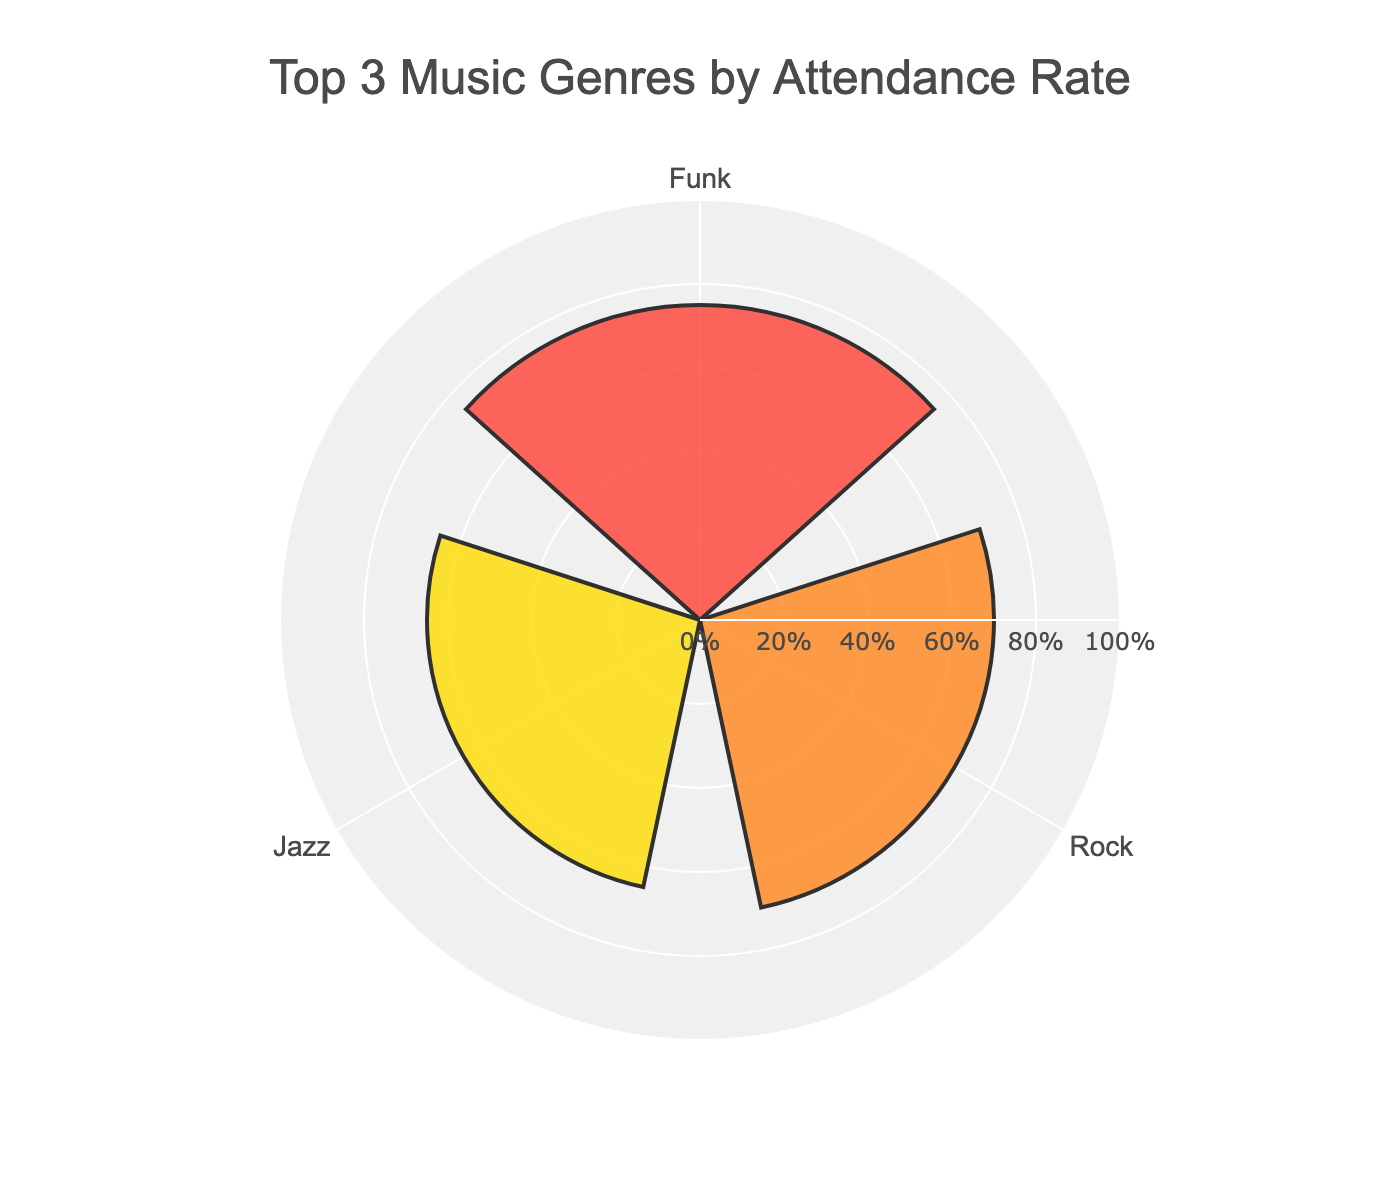What's the title of the chart? The title is placed at the top of the chart and is written in large, bold font.
Answer: Top 3 Music Genres by Attendance Rate What is the highest attendance rate among the music genres? The highest bar in the rose chart indicates the greatest attendance rate. The bar corresponding to Funk is the tallest.
Answer: 75% How many music genres are displayed in the figure? By counting the different labels on the angular axis, we see there are three different music genres.
Answer: 3 Which music genre has the lowest attendance rate among those shown? By comparing the heights of the bars, the shortest bar represents the lowest attendance rate. The Classical genre has the shortest bar.
Answer: Classical What is the difference in attendance rate between Funk and Classical music genres? The attendance rate for Funk is 75% and for Classical is 50%. The difference is calculated by subtracting 50 from 75.
Answer: 25% Which two music genres have a combined average attendance rate of 67.5%? First calculate the average attendance rate for each music genre: (Funk + Classical) / 2 = (75 + 50) / 2 = 62.5 and (Jazz + Classical) / 2 = (65 + 50) / 2 = 57.5, and (Rock + Classical) / 2 = (70 + 50) / 2 = 60, and (Jazz + Funk) / 2 = (65 + 75) / 2 = 70, and (Rock + Funk) / 2 = (70 + 75) / 2 = 72.5, and (Jazz + Rock) / 2 = (65 + 70) / 2 = 67.5. Therefore, Jazz and Rock have combined average rate.
Answer: Jazz and Rock Which genre is second in terms of attendance rate? The second tallest bar in the rose chart, after the Funk bar, is the Rock bar.
Answer: Rock Is there a significant difference between attendance rates of the Funk and Rock music genres? The attendance rate for Funk is 75% and for Rock is 70%. The difference is calculated by subtracting 70 from 75, which is 5.
Answer: No, the difference is only 5% How does the attendance rate for Jazz compare to that of Classical music? By observing the length of the bars, the Jazz bar is taller than the Classical bar. The attendance rate for Jazz is 65%, while for Classical it is 50%.
Answer: Jazz's rate is higher 